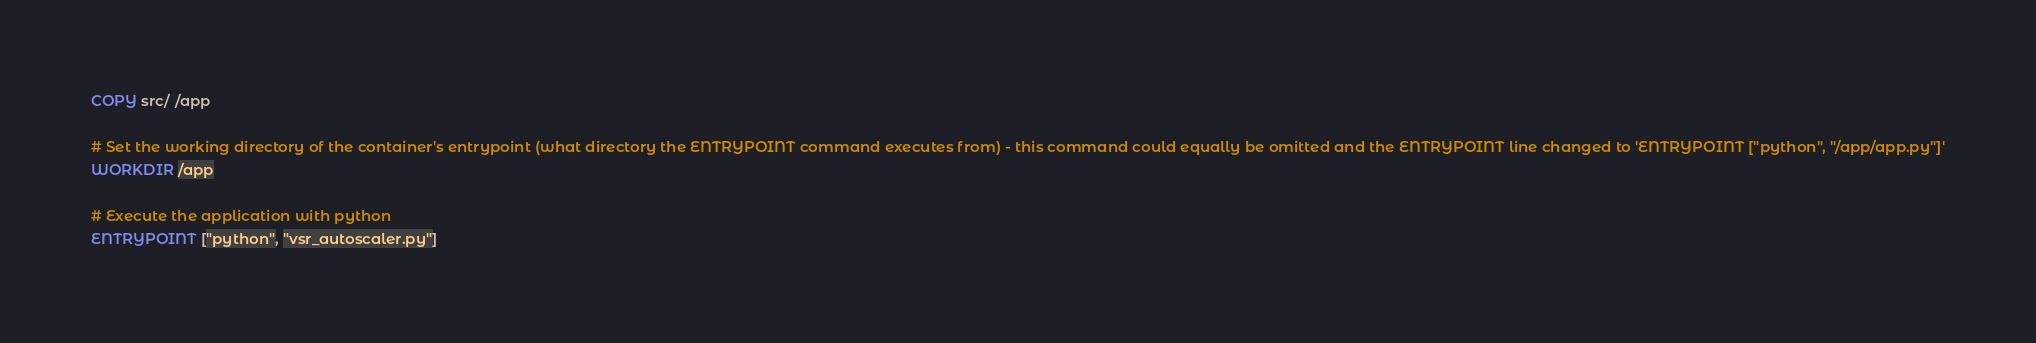Convert code to text. <code><loc_0><loc_0><loc_500><loc_500><_Dockerfile_>COPY src/ /app

# Set the working directory of the container's entrypoint (what directory the ENTRYPOINT command executes from) - this command could equally be omitted and the ENTRYPOINT line changed to 'ENTRYPOINT ["python", "/app/app.py"]'
WORKDIR /app

# Execute the application with python
ENTRYPOINT ["python", "vsr_autoscaler.py"]</code> 